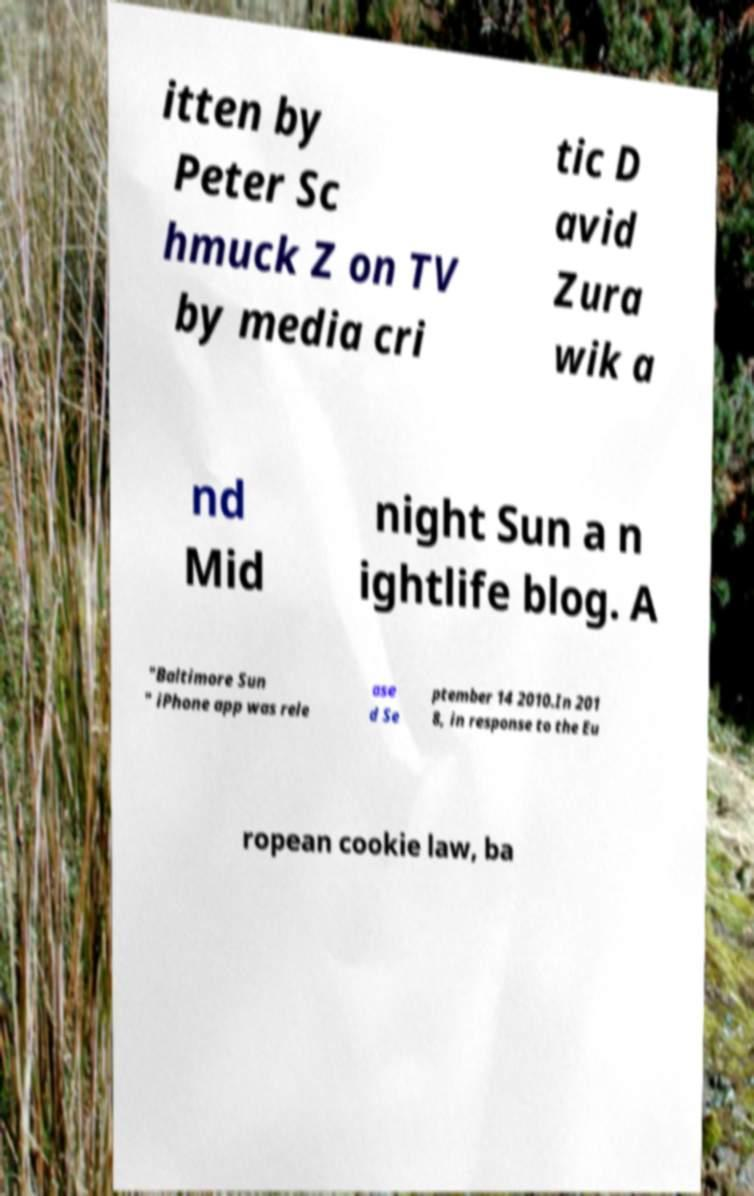Please identify and transcribe the text found in this image. itten by Peter Sc hmuck Z on TV by media cri tic D avid Zura wik a nd Mid night Sun a n ightlife blog. A "Baltimore Sun " iPhone app was rele ase d Se ptember 14 2010.In 201 8, in response to the Eu ropean cookie law, ba 